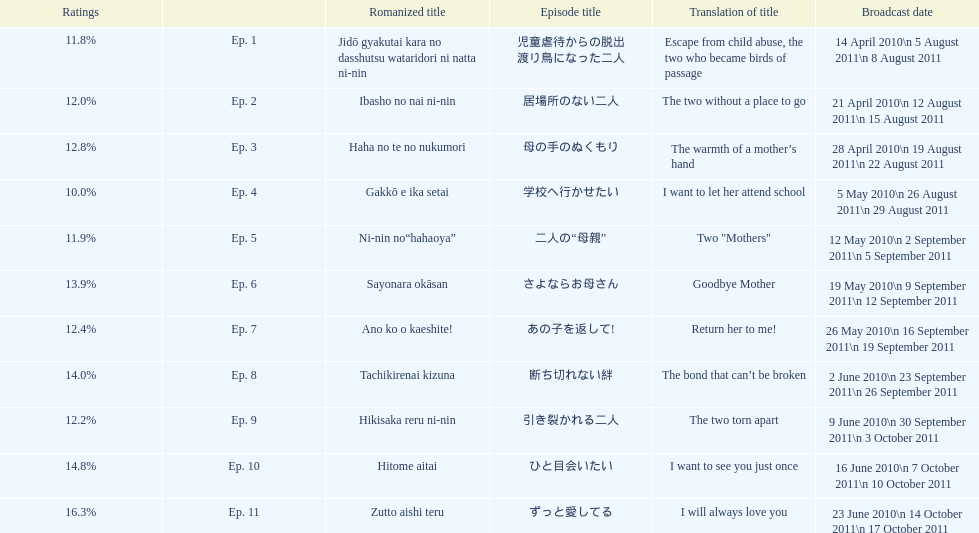How many episodes are listed? 11. 